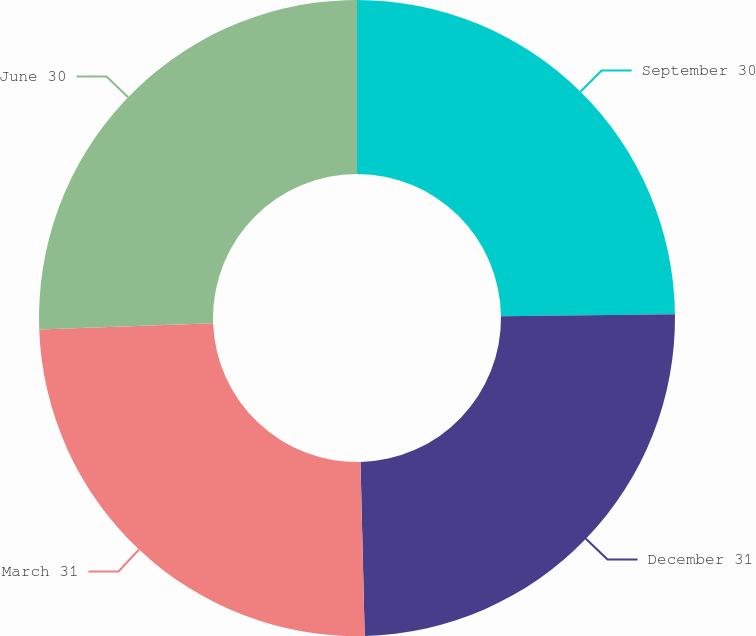Convert chart to OTSL. <chart><loc_0><loc_0><loc_500><loc_500><pie_chart><fcel>September 30<fcel>December 31<fcel>March 31<fcel>June 30<nl><fcel>24.81%<fcel>24.81%<fcel>24.81%<fcel>25.58%<nl></chart> 